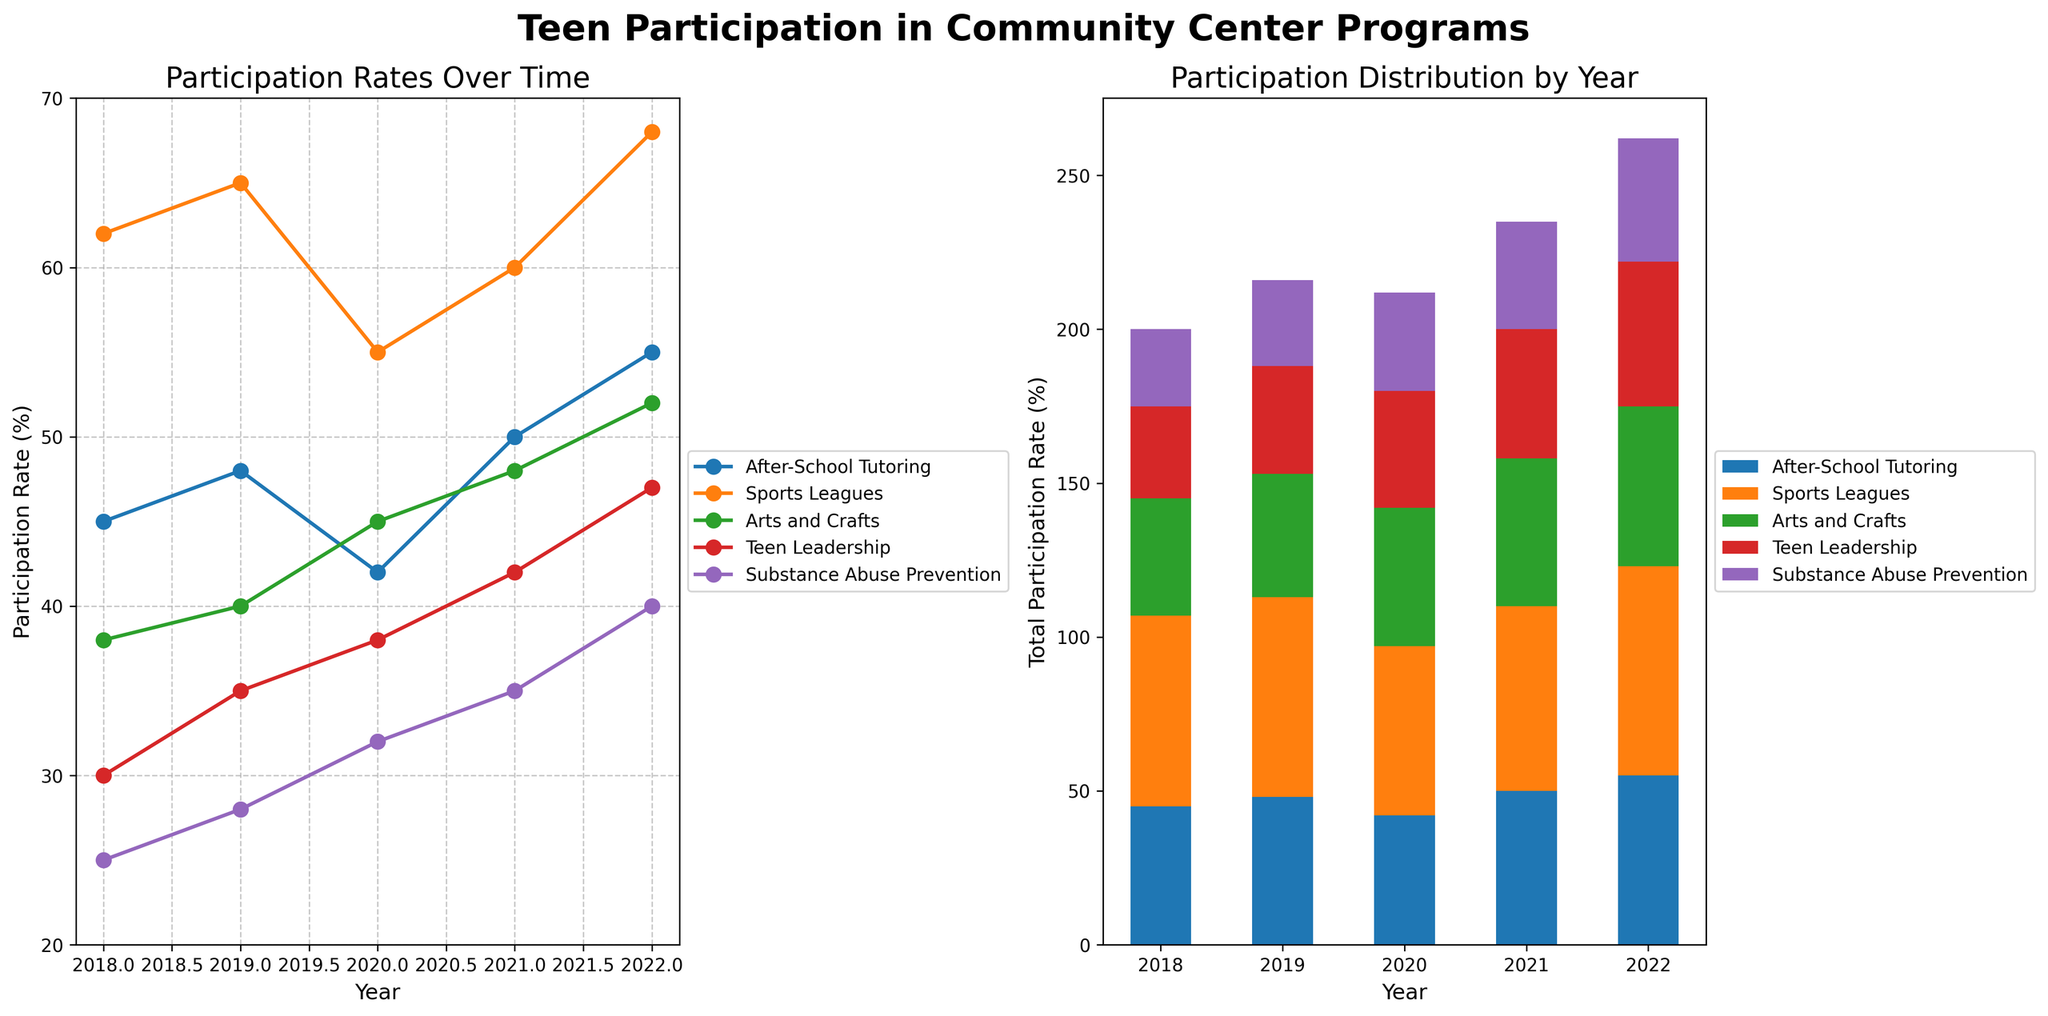Which program had the highest participation rate in 2022? From the line plot, look at the participation rates in 2022 for all programs and identify the highest value. Sports Leagues had the highest participation rate of 68% in 2022.
Answer: Sports Leagues Which program showed the most consistent increase in participation rate over the years? From the line plot, look at the trend lines for all programs. The After-School Tutoring program consistently increases its participation rate from 2018 to 2022.
Answer: After-School Tutoring What is the total participation rate across all programs in 2022? From the stacked bar chart, add the participation rates for all programs in 2022: After-School Tutoring (55), Sports Leagues (68), Arts and Crafts (52), Teen Leadership (47), and Substance Abuse Prevention (40). The total is 55 + 68 + 52 + 47 + 40 = 262.
Answer: 262 How did the participation rate for Arts and Crafts change from 2019 to 2022? From the line plot, compare the participation rates of Arts and Crafts in 2019 (40%) and 2022 (52%). Calculate the difference: 52 - 40 = 12.
Answer: Increased by 12% Which year had the lowest total participation rate across all programs? From the stacked bar chart, compare the total participation rates for each year. 2018 has the lowest total participation rate as it is visually the shortest bar.
Answer: 2018 What is the participation rate range (difference between highest and lowest) for Teen Leadership from 2018 to 2022? From the line plot, identify the highest participation rate for Teen Leadership (47% in 2022) and the lowest (30% in 2018). Calculate the difference: 47 - 30 = 17.
Answer: 17 Which program had the smallest increase in participation rate from 2018 to 2022? From the line plot, compare the difference in participation rates between 2018 and 2022 for each program. Substance Abuse Prevention had the smallest increase from 25% in 2018 to 40% in 2022.
Answer: Substance Abuse Prevention By how much did the participation rate for Sports Leagues change from 2018 to 2020? From the line plot, compare the participation rates of Sports Leagues in 2018 (62%) and 2020 (55%). Calculate the difference: 62 - 55 = 7.
Answer: Decreased by 7% Between which consecutive years did After-School Tutoring see the highest increase in participation rate? From the line plot, compare the year-to-year changes in participation rates for After-School Tutoring. The highest increase occurred between 2020 (42%) and 2021 (50%), with an increase of 8%.
Answer: 2020 to 2021 